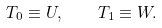Convert formula to latex. <formula><loc_0><loc_0><loc_500><loc_500>T _ { 0 } \equiv U , \quad T _ { 1 } \equiv W .</formula> 